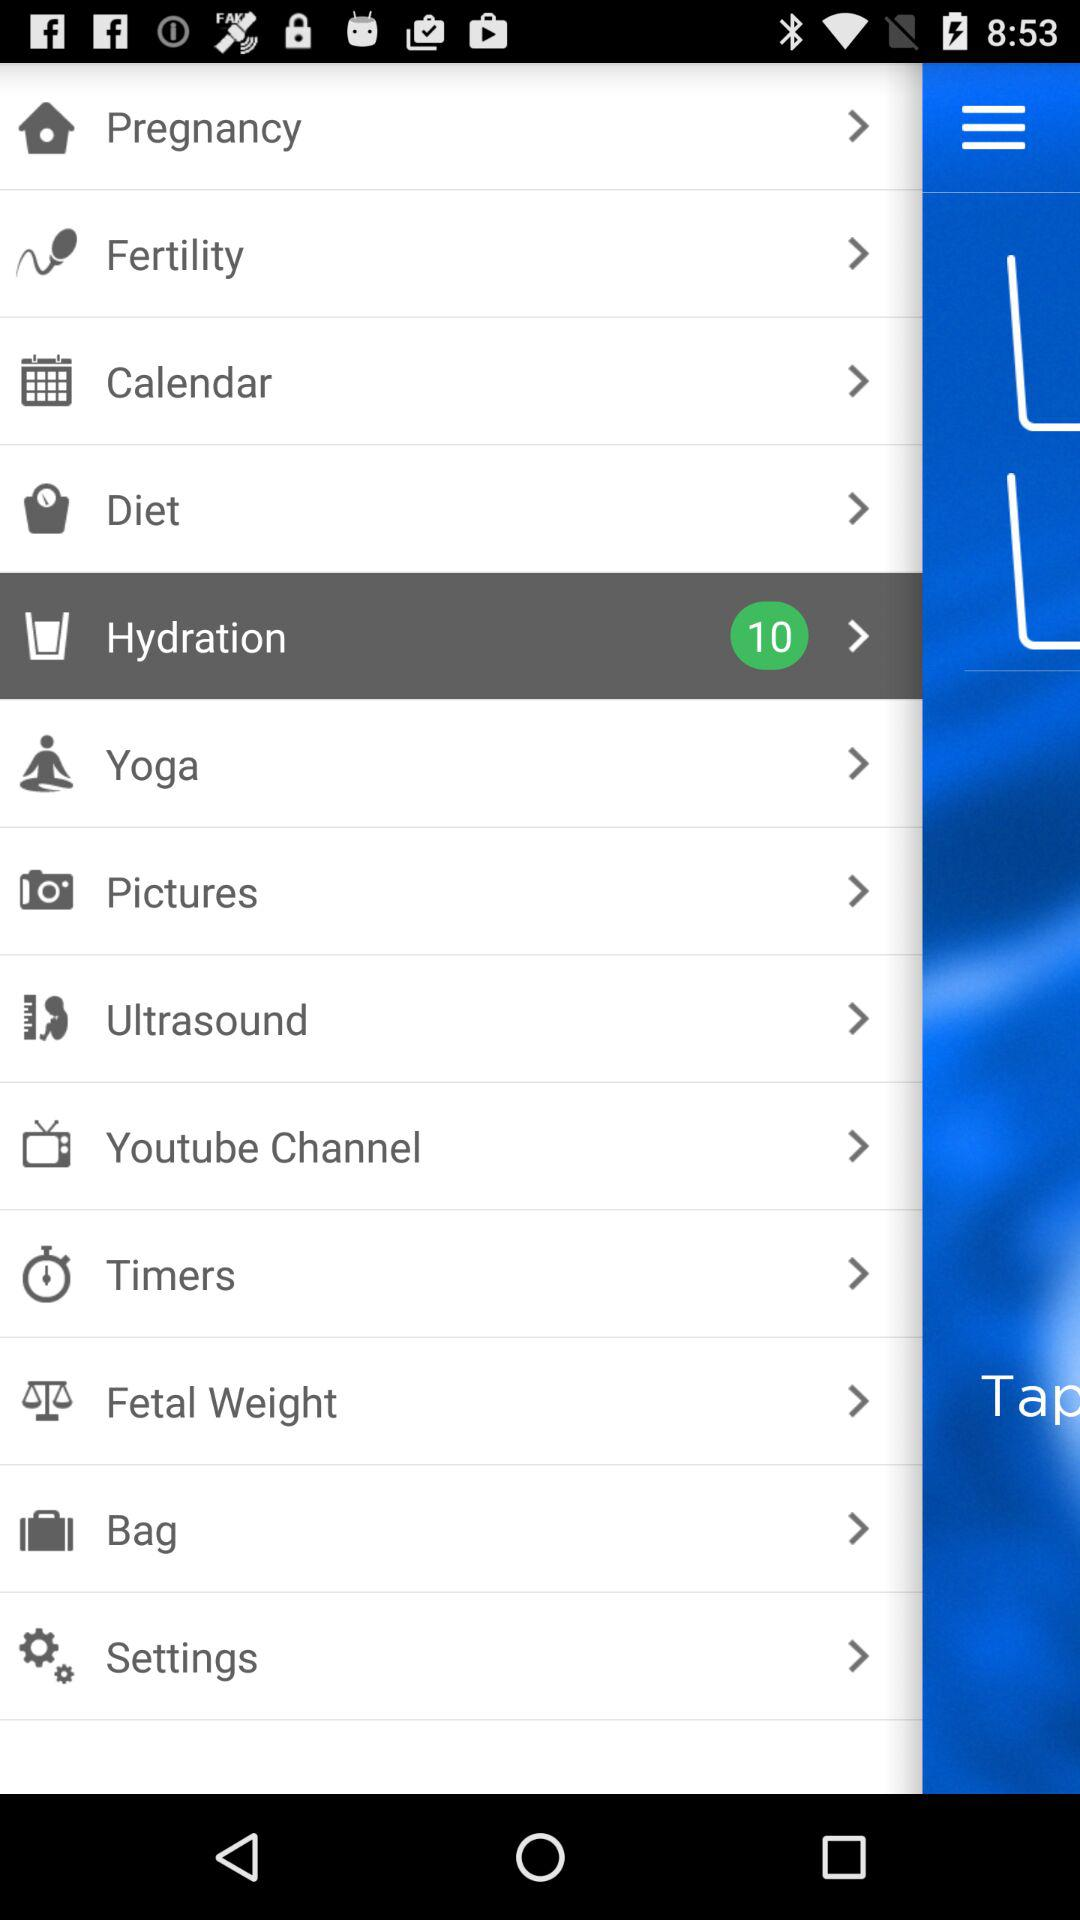Which item is selected? The selected item is "Hydration". 